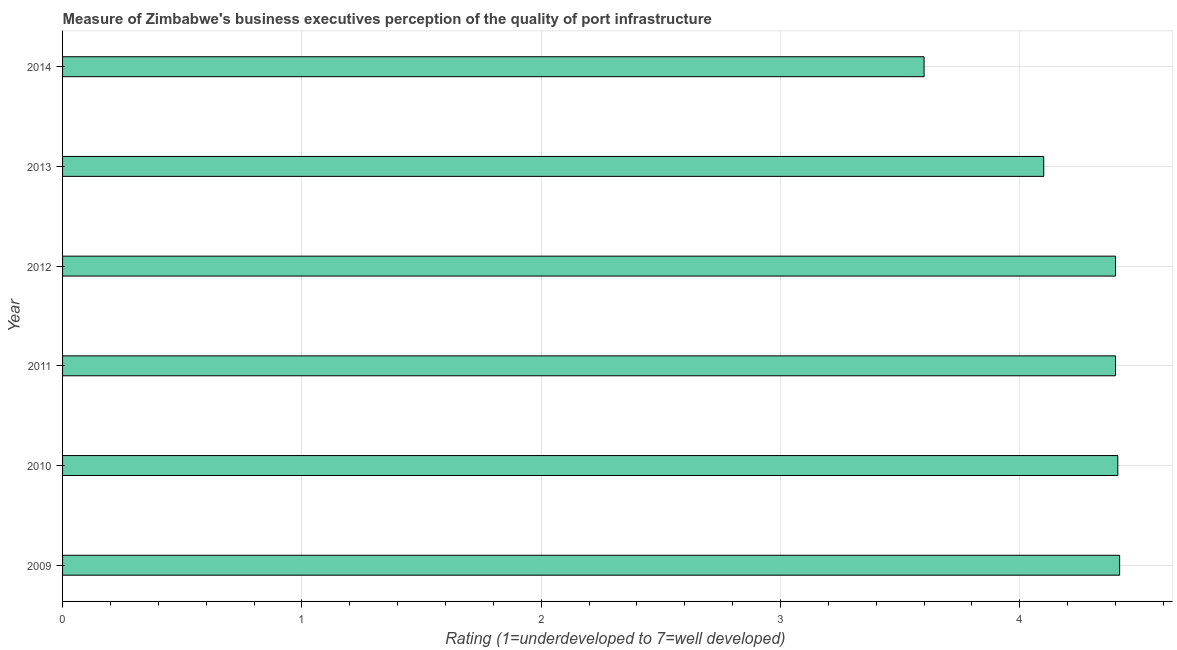Does the graph contain any zero values?
Your answer should be very brief. No. What is the title of the graph?
Provide a short and direct response. Measure of Zimbabwe's business executives perception of the quality of port infrastructure. What is the label or title of the X-axis?
Make the answer very short. Rating (1=underdeveloped to 7=well developed) . Across all years, what is the maximum rating measuring quality of port infrastructure?
Give a very brief answer. 4.42. Across all years, what is the minimum rating measuring quality of port infrastructure?
Ensure brevity in your answer.  3.6. What is the sum of the rating measuring quality of port infrastructure?
Your response must be concise. 25.33. What is the difference between the rating measuring quality of port infrastructure in 2010 and 2013?
Provide a succinct answer. 0.31. What is the average rating measuring quality of port infrastructure per year?
Provide a short and direct response. 4.22. In how many years, is the rating measuring quality of port infrastructure greater than 0.2 ?
Give a very brief answer. 6. Do a majority of the years between 2013 and 2012 (inclusive) have rating measuring quality of port infrastructure greater than 2.8 ?
Offer a very short reply. No. What is the difference between the highest and the second highest rating measuring quality of port infrastructure?
Ensure brevity in your answer.  0.01. What is the difference between the highest and the lowest rating measuring quality of port infrastructure?
Provide a succinct answer. 0.82. How many bars are there?
Make the answer very short. 6. Are all the bars in the graph horizontal?
Keep it short and to the point. Yes. What is the difference between two consecutive major ticks on the X-axis?
Ensure brevity in your answer.  1. Are the values on the major ticks of X-axis written in scientific E-notation?
Ensure brevity in your answer.  No. What is the Rating (1=underdeveloped to 7=well developed)  in 2009?
Provide a succinct answer. 4.42. What is the Rating (1=underdeveloped to 7=well developed)  of 2010?
Provide a short and direct response. 4.41. What is the Rating (1=underdeveloped to 7=well developed)  of 2012?
Keep it short and to the point. 4.4. What is the Rating (1=underdeveloped to 7=well developed)  of 2014?
Your response must be concise. 3.6. What is the difference between the Rating (1=underdeveloped to 7=well developed)  in 2009 and 2010?
Your answer should be very brief. 0.01. What is the difference between the Rating (1=underdeveloped to 7=well developed)  in 2009 and 2011?
Your response must be concise. 0.02. What is the difference between the Rating (1=underdeveloped to 7=well developed)  in 2009 and 2012?
Make the answer very short. 0.02. What is the difference between the Rating (1=underdeveloped to 7=well developed)  in 2009 and 2013?
Provide a short and direct response. 0.32. What is the difference between the Rating (1=underdeveloped to 7=well developed)  in 2009 and 2014?
Give a very brief answer. 0.82. What is the difference between the Rating (1=underdeveloped to 7=well developed)  in 2010 and 2011?
Provide a short and direct response. 0.01. What is the difference between the Rating (1=underdeveloped to 7=well developed)  in 2010 and 2012?
Keep it short and to the point. 0.01. What is the difference between the Rating (1=underdeveloped to 7=well developed)  in 2010 and 2013?
Your response must be concise. 0.31. What is the difference between the Rating (1=underdeveloped to 7=well developed)  in 2010 and 2014?
Your response must be concise. 0.81. What is the difference between the Rating (1=underdeveloped to 7=well developed)  in 2011 and 2014?
Offer a very short reply. 0.8. What is the difference between the Rating (1=underdeveloped to 7=well developed)  in 2012 and 2013?
Make the answer very short. 0.3. What is the difference between the Rating (1=underdeveloped to 7=well developed)  in 2012 and 2014?
Provide a succinct answer. 0.8. What is the difference between the Rating (1=underdeveloped to 7=well developed)  in 2013 and 2014?
Give a very brief answer. 0.5. What is the ratio of the Rating (1=underdeveloped to 7=well developed)  in 2009 to that in 2010?
Ensure brevity in your answer.  1. What is the ratio of the Rating (1=underdeveloped to 7=well developed)  in 2009 to that in 2012?
Offer a very short reply. 1. What is the ratio of the Rating (1=underdeveloped to 7=well developed)  in 2009 to that in 2013?
Your answer should be very brief. 1.08. What is the ratio of the Rating (1=underdeveloped to 7=well developed)  in 2009 to that in 2014?
Ensure brevity in your answer.  1.23. What is the ratio of the Rating (1=underdeveloped to 7=well developed)  in 2010 to that in 2011?
Your answer should be compact. 1. What is the ratio of the Rating (1=underdeveloped to 7=well developed)  in 2010 to that in 2012?
Keep it short and to the point. 1. What is the ratio of the Rating (1=underdeveloped to 7=well developed)  in 2010 to that in 2013?
Provide a short and direct response. 1.07. What is the ratio of the Rating (1=underdeveloped to 7=well developed)  in 2010 to that in 2014?
Provide a succinct answer. 1.23. What is the ratio of the Rating (1=underdeveloped to 7=well developed)  in 2011 to that in 2013?
Keep it short and to the point. 1.07. What is the ratio of the Rating (1=underdeveloped to 7=well developed)  in 2011 to that in 2014?
Your answer should be compact. 1.22. What is the ratio of the Rating (1=underdeveloped to 7=well developed)  in 2012 to that in 2013?
Make the answer very short. 1.07. What is the ratio of the Rating (1=underdeveloped to 7=well developed)  in 2012 to that in 2014?
Provide a succinct answer. 1.22. What is the ratio of the Rating (1=underdeveloped to 7=well developed)  in 2013 to that in 2014?
Ensure brevity in your answer.  1.14. 